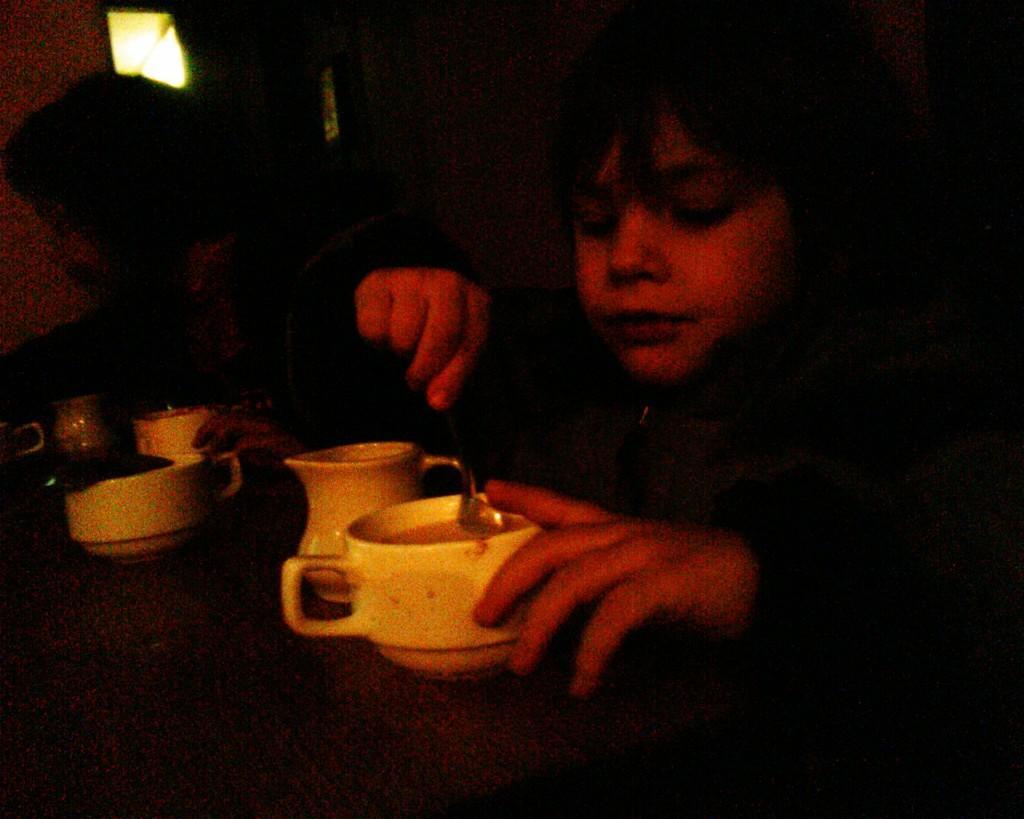In one or two sentences, can you explain what this image depicts? In this image I can see a child. On the table there is a cup,spoon and some glasses. 